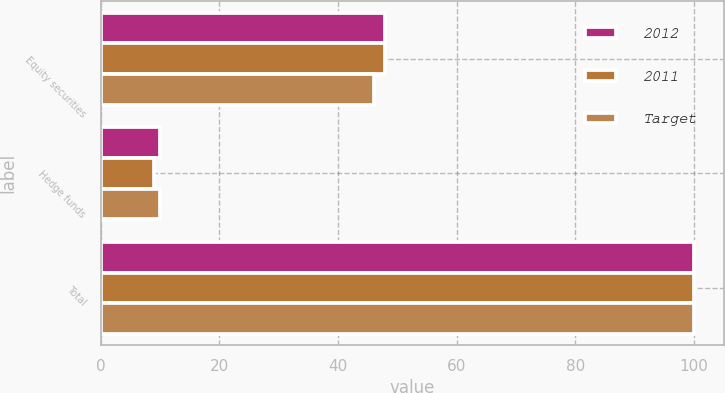Convert chart. <chart><loc_0><loc_0><loc_500><loc_500><stacked_bar_chart><ecel><fcel>Equity securities<fcel>Hedge funds<fcel>Total<nl><fcel>2012<fcel>48<fcel>10<fcel>100<nl><fcel>2011<fcel>48<fcel>9<fcel>100<nl><fcel>Target<fcel>46<fcel>10<fcel>100<nl></chart> 